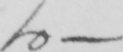What is written in this line of handwriting? to  _ 